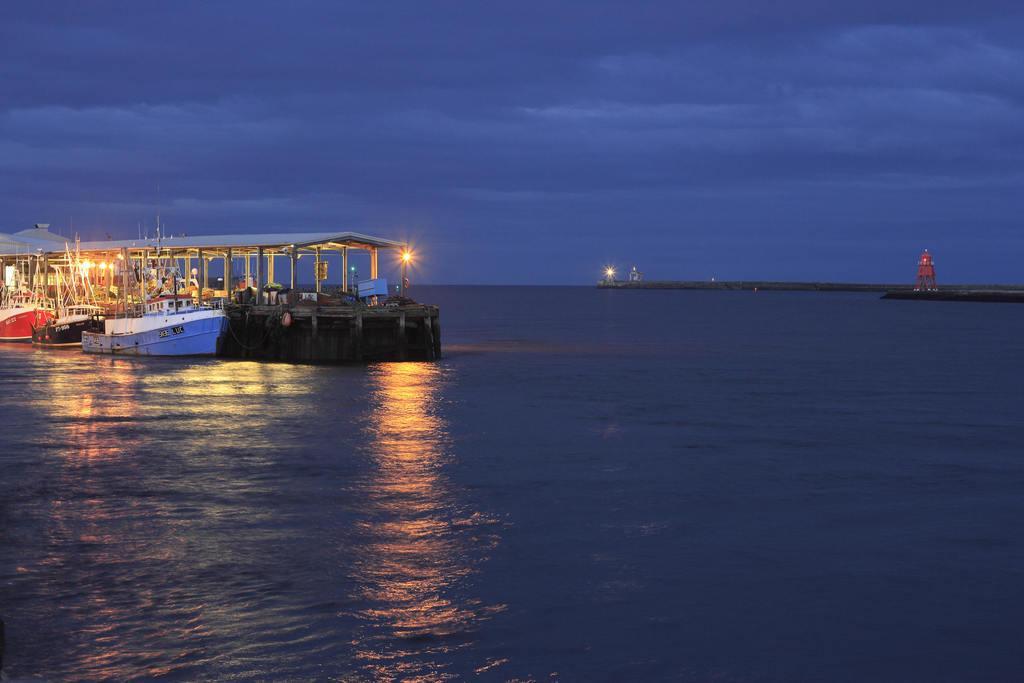How would you summarize this image in a sentence or two? In the image there is a boat and beside that there are three ships on a water surface. 